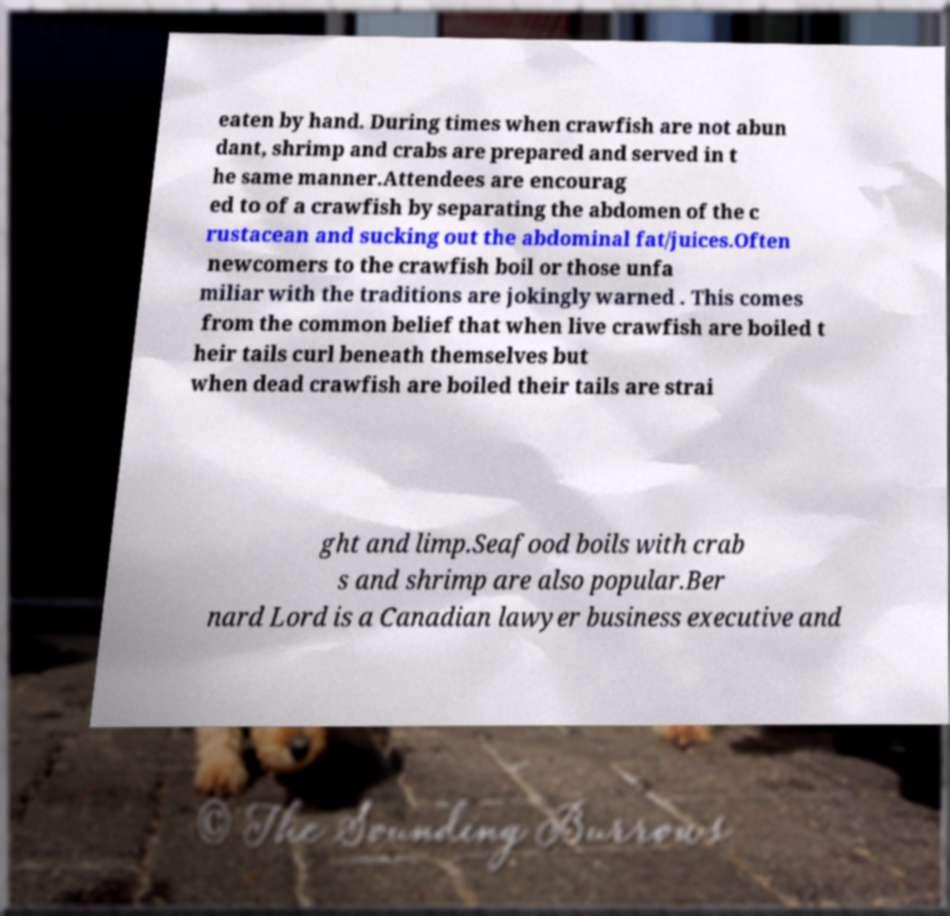Can you accurately transcribe the text from the provided image for me? eaten by hand. During times when crawfish are not abun dant, shrimp and crabs are prepared and served in t he same manner.Attendees are encourag ed to of a crawfish by separating the abdomen of the c rustacean and sucking out the abdominal fat/juices.Often newcomers to the crawfish boil or those unfa miliar with the traditions are jokingly warned . This comes from the common belief that when live crawfish are boiled t heir tails curl beneath themselves but when dead crawfish are boiled their tails are strai ght and limp.Seafood boils with crab s and shrimp are also popular.Ber nard Lord is a Canadian lawyer business executive and 